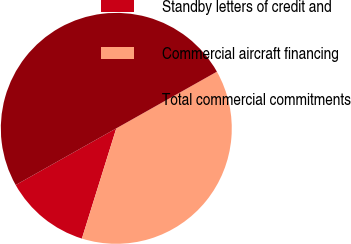<chart> <loc_0><loc_0><loc_500><loc_500><pie_chart><fcel>Standby letters of credit and<fcel>Commercial aircraft financing<fcel>Total commercial commitments<nl><fcel>12.02%<fcel>37.98%<fcel>50.0%<nl></chart> 